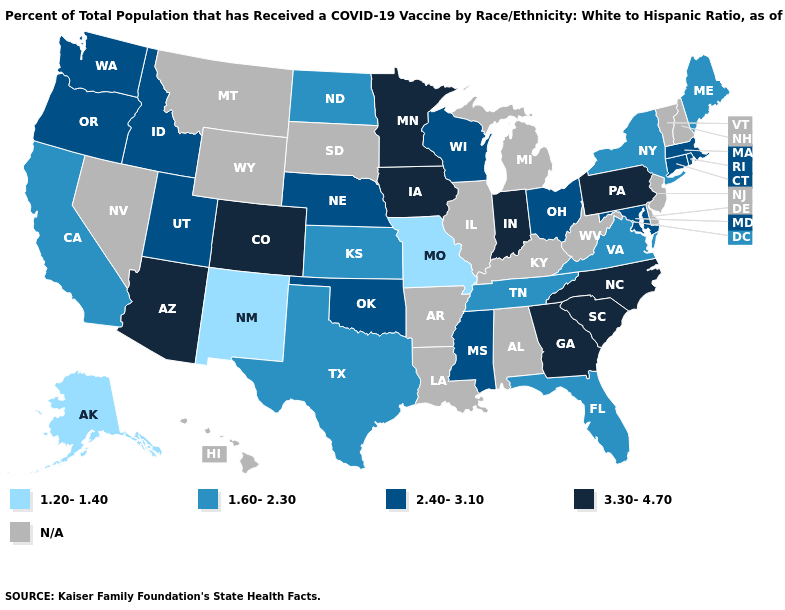Does Pennsylvania have the highest value in the Northeast?
Write a very short answer. Yes. What is the value of New Hampshire?
Concise answer only. N/A. Name the states that have a value in the range 1.20-1.40?
Concise answer only. Alaska, Missouri, New Mexico. Name the states that have a value in the range N/A?
Short answer required. Alabama, Arkansas, Delaware, Hawaii, Illinois, Kentucky, Louisiana, Michigan, Montana, Nevada, New Hampshire, New Jersey, South Dakota, Vermont, West Virginia, Wyoming. Name the states that have a value in the range 2.40-3.10?
Answer briefly. Connecticut, Idaho, Maryland, Massachusetts, Mississippi, Nebraska, Ohio, Oklahoma, Oregon, Rhode Island, Utah, Washington, Wisconsin. Name the states that have a value in the range 1.20-1.40?
Write a very short answer. Alaska, Missouri, New Mexico. What is the highest value in the Northeast ?
Give a very brief answer. 3.30-4.70. Does Arizona have the lowest value in the USA?
Answer briefly. No. What is the lowest value in the West?
Keep it brief. 1.20-1.40. What is the value of Oklahoma?
Concise answer only. 2.40-3.10. Name the states that have a value in the range N/A?
Short answer required. Alabama, Arkansas, Delaware, Hawaii, Illinois, Kentucky, Louisiana, Michigan, Montana, Nevada, New Hampshire, New Jersey, South Dakota, Vermont, West Virginia, Wyoming. Name the states that have a value in the range 1.60-2.30?
Answer briefly. California, Florida, Kansas, Maine, New York, North Dakota, Tennessee, Texas, Virginia. Which states have the highest value in the USA?
Write a very short answer. Arizona, Colorado, Georgia, Indiana, Iowa, Minnesota, North Carolina, Pennsylvania, South Carolina. Among the states that border Minnesota , which have the lowest value?
Quick response, please. North Dakota. 